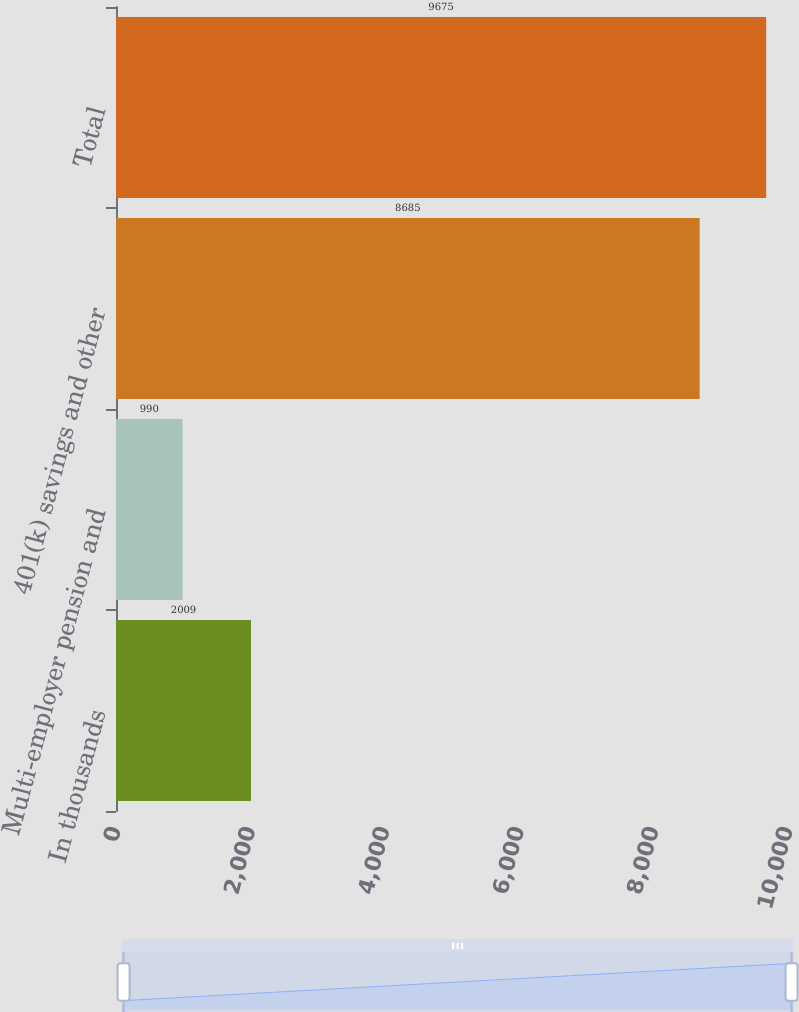Convert chart to OTSL. <chart><loc_0><loc_0><loc_500><loc_500><bar_chart><fcel>In thousands<fcel>Multi-employer pension and<fcel>401(k) savings and other<fcel>Total<nl><fcel>2009<fcel>990<fcel>8685<fcel>9675<nl></chart> 